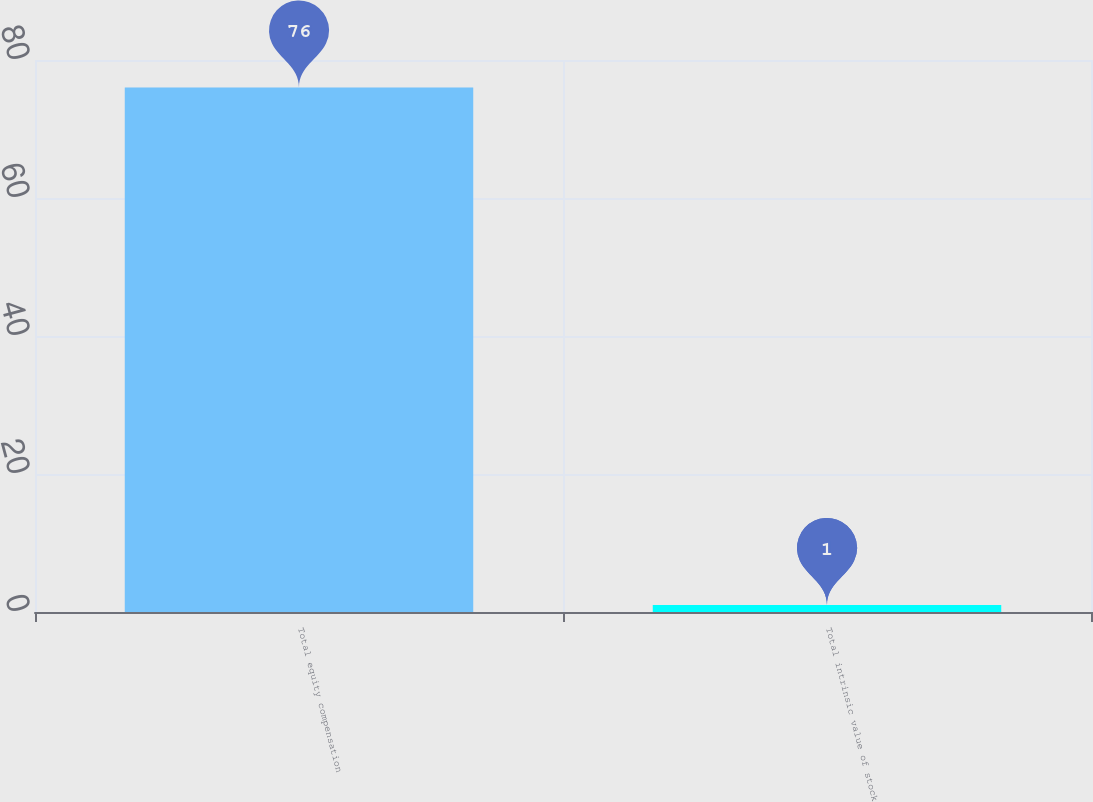Convert chart. <chart><loc_0><loc_0><loc_500><loc_500><bar_chart><fcel>Total equity compensation<fcel>Total intrinsic value of stock<nl><fcel>76<fcel>1<nl></chart> 